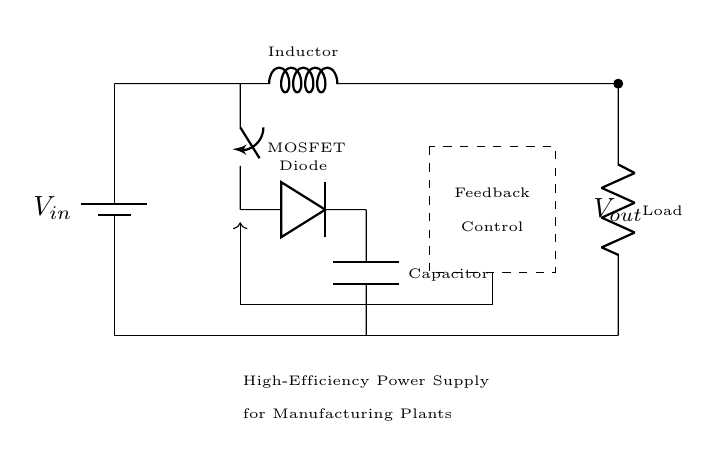What is the input voltage of the circuit? The input voltage is indicated by the battery symbol labeled as V_{in}, which represents the voltage supply feeding into the circuit.
Answer: V_{in} What component is used to control the voltage output? The MOSFET component acts as a switch, controlled by a feedback mechanism in the circuit to regulate the output voltage based on the load requirements.
Answer: MOSFET What does the dashed rectangle represent in the circuit? The dashed rectangle encloses the feedback control unit, which assesses the output voltage and adjusts the switching of the MOSFET accordingly to maintain efficiency and stability.
Answer: Feedback Control Which component serves as the energy storage device in the circuit? The capacitor is the energy storage element that smooths out the output voltage by storing charge, enabling a stable voltage supply to the load.
Answer: Capacitor How many primary components are there in this circuit? The circuit consists of five primary components: a battery (input), a MOSFET, a diode, an inductor, and a capacitor, as well as a load resistor at the output.
Answer: Five What is the purpose of the diode in this circuit? The diode allows current to flow in only one direction, preventing backflow and protecting the circuit while ensuring that the inductor can maintain current during switching.
Answer: Protecting What type of power supply circuit is illustrated? This circuit is a buck converter, which is designed to step down the voltage from the battery while maximizing efficiency, critical for reducing energy costs in manufacturing plants.
Answer: Buck converter 